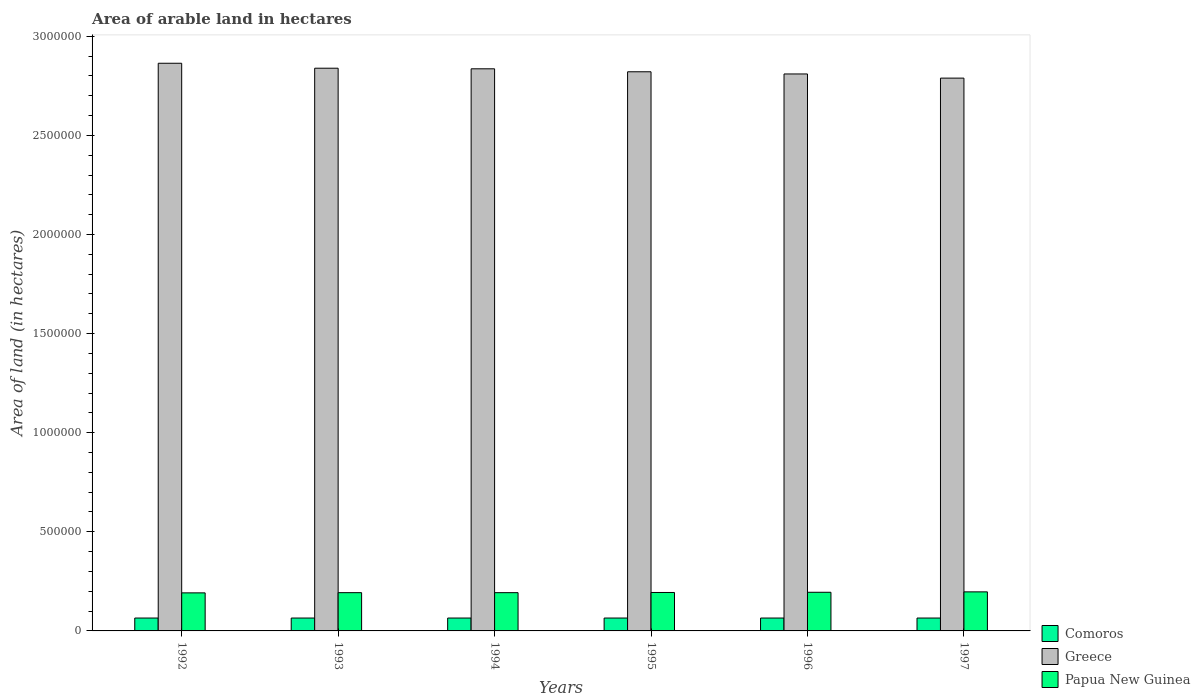How many groups of bars are there?
Offer a terse response. 6. Are the number of bars per tick equal to the number of legend labels?
Give a very brief answer. Yes. Are the number of bars on each tick of the X-axis equal?
Your answer should be very brief. Yes. What is the total arable land in Papua New Guinea in 1996?
Ensure brevity in your answer.  1.95e+05. Across all years, what is the maximum total arable land in Papua New Guinea?
Ensure brevity in your answer.  1.97e+05. Across all years, what is the minimum total arable land in Comoros?
Ensure brevity in your answer.  6.50e+04. In which year was the total arable land in Comoros maximum?
Offer a very short reply. 1992. In which year was the total arable land in Comoros minimum?
Make the answer very short. 1992. What is the total total arable land in Papua New Guinea in the graph?
Offer a very short reply. 1.16e+06. What is the difference between the total arable land in Papua New Guinea in 1992 and the total arable land in Comoros in 1997?
Provide a short and direct response. 1.27e+05. What is the average total arable land in Greece per year?
Offer a terse response. 2.83e+06. In the year 1997, what is the difference between the total arable land in Papua New Guinea and total arable land in Greece?
Give a very brief answer. -2.59e+06. What is the ratio of the total arable land in Greece in 1992 to that in 1997?
Provide a short and direct response. 1.03. Is the total arable land in Comoros in 1993 less than that in 1994?
Offer a terse response. No. Is the difference between the total arable land in Papua New Guinea in 1996 and 1997 greater than the difference between the total arable land in Greece in 1996 and 1997?
Offer a terse response. No. What is the difference between the highest and the lowest total arable land in Comoros?
Keep it short and to the point. 0. Is the sum of the total arable land in Comoros in 1996 and 1997 greater than the maximum total arable land in Papua New Guinea across all years?
Give a very brief answer. No. What does the 3rd bar from the left in 1994 represents?
Your answer should be compact. Papua New Guinea. What does the 1st bar from the right in 1992 represents?
Your answer should be very brief. Papua New Guinea. Is it the case that in every year, the sum of the total arable land in Greece and total arable land in Comoros is greater than the total arable land in Papua New Guinea?
Provide a short and direct response. Yes. How many bars are there?
Your answer should be very brief. 18. Are all the bars in the graph horizontal?
Your answer should be very brief. No. How many years are there in the graph?
Make the answer very short. 6. Are the values on the major ticks of Y-axis written in scientific E-notation?
Ensure brevity in your answer.  No. Where does the legend appear in the graph?
Your answer should be compact. Bottom right. How many legend labels are there?
Offer a terse response. 3. How are the legend labels stacked?
Provide a succinct answer. Vertical. What is the title of the graph?
Your answer should be compact. Area of arable land in hectares. Does "Venezuela" appear as one of the legend labels in the graph?
Ensure brevity in your answer.  No. What is the label or title of the X-axis?
Keep it short and to the point. Years. What is the label or title of the Y-axis?
Your answer should be compact. Area of land (in hectares). What is the Area of land (in hectares) of Comoros in 1992?
Offer a terse response. 6.50e+04. What is the Area of land (in hectares) of Greece in 1992?
Ensure brevity in your answer.  2.86e+06. What is the Area of land (in hectares) in Papua New Guinea in 1992?
Make the answer very short. 1.92e+05. What is the Area of land (in hectares) in Comoros in 1993?
Your response must be concise. 6.50e+04. What is the Area of land (in hectares) in Greece in 1993?
Give a very brief answer. 2.84e+06. What is the Area of land (in hectares) in Papua New Guinea in 1993?
Offer a very short reply. 1.93e+05. What is the Area of land (in hectares) of Comoros in 1994?
Provide a succinct answer. 6.50e+04. What is the Area of land (in hectares) of Greece in 1994?
Give a very brief answer. 2.84e+06. What is the Area of land (in hectares) of Papua New Guinea in 1994?
Keep it short and to the point. 1.93e+05. What is the Area of land (in hectares) in Comoros in 1995?
Provide a short and direct response. 6.50e+04. What is the Area of land (in hectares) in Greece in 1995?
Ensure brevity in your answer.  2.82e+06. What is the Area of land (in hectares) of Papua New Guinea in 1995?
Make the answer very short. 1.94e+05. What is the Area of land (in hectares) of Comoros in 1996?
Keep it short and to the point. 6.50e+04. What is the Area of land (in hectares) of Greece in 1996?
Your response must be concise. 2.81e+06. What is the Area of land (in hectares) in Papua New Guinea in 1996?
Your response must be concise. 1.95e+05. What is the Area of land (in hectares) in Comoros in 1997?
Offer a terse response. 6.50e+04. What is the Area of land (in hectares) in Greece in 1997?
Provide a short and direct response. 2.79e+06. What is the Area of land (in hectares) in Papua New Guinea in 1997?
Your response must be concise. 1.97e+05. Across all years, what is the maximum Area of land (in hectares) in Comoros?
Give a very brief answer. 6.50e+04. Across all years, what is the maximum Area of land (in hectares) in Greece?
Give a very brief answer. 2.86e+06. Across all years, what is the maximum Area of land (in hectares) of Papua New Guinea?
Ensure brevity in your answer.  1.97e+05. Across all years, what is the minimum Area of land (in hectares) in Comoros?
Your answer should be compact. 6.50e+04. Across all years, what is the minimum Area of land (in hectares) in Greece?
Keep it short and to the point. 2.79e+06. Across all years, what is the minimum Area of land (in hectares) of Papua New Guinea?
Make the answer very short. 1.92e+05. What is the total Area of land (in hectares) in Greece in the graph?
Make the answer very short. 1.70e+07. What is the total Area of land (in hectares) of Papua New Guinea in the graph?
Your response must be concise. 1.16e+06. What is the difference between the Area of land (in hectares) of Greece in 1992 and that in 1993?
Ensure brevity in your answer.  2.50e+04. What is the difference between the Area of land (in hectares) in Papua New Guinea in 1992 and that in 1993?
Provide a short and direct response. -1000. What is the difference between the Area of land (in hectares) in Greece in 1992 and that in 1994?
Provide a succinct answer. 2.80e+04. What is the difference between the Area of land (in hectares) in Papua New Guinea in 1992 and that in 1994?
Your answer should be compact. -1000. What is the difference between the Area of land (in hectares) in Comoros in 1992 and that in 1995?
Your answer should be compact. 0. What is the difference between the Area of land (in hectares) in Greece in 1992 and that in 1995?
Your answer should be very brief. 4.30e+04. What is the difference between the Area of land (in hectares) of Papua New Guinea in 1992 and that in 1995?
Your answer should be compact. -2000. What is the difference between the Area of land (in hectares) in Greece in 1992 and that in 1996?
Offer a terse response. 5.40e+04. What is the difference between the Area of land (in hectares) of Papua New Guinea in 1992 and that in 1996?
Provide a succinct answer. -3000. What is the difference between the Area of land (in hectares) of Greece in 1992 and that in 1997?
Provide a short and direct response. 7.50e+04. What is the difference between the Area of land (in hectares) in Papua New Guinea in 1992 and that in 1997?
Your response must be concise. -5000. What is the difference between the Area of land (in hectares) in Greece in 1993 and that in 1994?
Make the answer very short. 3000. What is the difference between the Area of land (in hectares) of Papua New Guinea in 1993 and that in 1994?
Offer a terse response. 0. What is the difference between the Area of land (in hectares) of Comoros in 1993 and that in 1995?
Your answer should be very brief. 0. What is the difference between the Area of land (in hectares) of Greece in 1993 and that in 1995?
Provide a short and direct response. 1.80e+04. What is the difference between the Area of land (in hectares) of Papua New Guinea in 1993 and that in 1995?
Make the answer very short. -1000. What is the difference between the Area of land (in hectares) of Comoros in 1993 and that in 1996?
Make the answer very short. 0. What is the difference between the Area of land (in hectares) in Greece in 1993 and that in 1996?
Ensure brevity in your answer.  2.90e+04. What is the difference between the Area of land (in hectares) in Papua New Guinea in 1993 and that in 1996?
Provide a short and direct response. -2000. What is the difference between the Area of land (in hectares) of Greece in 1993 and that in 1997?
Give a very brief answer. 5.00e+04. What is the difference between the Area of land (in hectares) in Papua New Guinea in 1993 and that in 1997?
Offer a terse response. -4000. What is the difference between the Area of land (in hectares) in Comoros in 1994 and that in 1995?
Provide a succinct answer. 0. What is the difference between the Area of land (in hectares) in Greece in 1994 and that in 1995?
Offer a terse response. 1.50e+04. What is the difference between the Area of land (in hectares) of Papua New Guinea in 1994 and that in 1995?
Your response must be concise. -1000. What is the difference between the Area of land (in hectares) of Greece in 1994 and that in 1996?
Offer a very short reply. 2.60e+04. What is the difference between the Area of land (in hectares) of Papua New Guinea in 1994 and that in 1996?
Offer a very short reply. -2000. What is the difference between the Area of land (in hectares) of Comoros in 1994 and that in 1997?
Make the answer very short. 0. What is the difference between the Area of land (in hectares) of Greece in 1994 and that in 1997?
Provide a succinct answer. 4.70e+04. What is the difference between the Area of land (in hectares) in Papua New Guinea in 1994 and that in 1997?
Offer a very short reply. -4000. What is the difference between the Area of land (in hectares) of Greece in 1995 and that in 1996?
Your answer should be very brief. 1.10e+04. What is the difference between the Area of land (in hectares) in Papua New Guinea in 1995 and that in 1996?
Offer a terse response. -1000. What is the difference between the Area of land (in hectares) of Greece in 1995 and that in 1997?
Your answer should be compact. 3.20e+04. What is the difference between the Area of land (in hectares) of Papua New Guinea in 1995 and that in 1997?
Provide a succinct answer. -3000. What is the difference between the Area of land (in hectares) in Greece in 1996 and that in 1997?
Provide a short and direct response. 2.10e+04. What is the difference between the Area of land (in hectares) of Papua New Guinea in 1996 and that in 1997?
Provide a short and direct response. -2000. What is the difference between the Area of land (in hectares) of Comoros in 1992 and the Area of land (in hectares) of Greece in 1993?
Offer a very short reply. -2.77e+06. What is the difference between the Area of land (in hectares) of Comoros in 1992 and the Area of land (in hectares) of Papua New Guinea in 1993?
Provide a succinct answer. -1.28e+05. What is the difference between the Area of land (in hectares) in Greece in 1992 and the Area of land (in hectares) in Papua New Guinea in 1993?
Make the answer very short. 2.67e+06. What is the difference between the Area of land (in hectares) of Comoros in 1992 and the Area of land (in hectares) of Greece in 1994?
Provide a succinct answer. -2.77e+06. What is the difference between the Area of land (in hectares) of Comoros in 1992 and the Area of land (in hectares) of Papua New Guinea in 1994?
Keep it short and to the point. -1.28e+05. What is the difference between the Area of land (in hectares) of Greece in 1992 and the Area of land (in hectares) of Papua New Guinea in 1994?
Provide a succinct answer. 2.67e+06. What is the difference between the Area of land (in hectares) of Comoros in 1992 and the Area of land (in hectares) of Greece in 1995?
Keep it short and to the point. -2.76e+06. What is the difference between the Area of land (in hectares) of Comoros in 1992 and the Area of land (in hectares) of Papua New Guinea in 1995?
Give a very brief answer. -1.29e+05. What is the difference between the Area of land (in hectares) in Greece in 1992 and the Area of land (in hectares) in Papua New Guinea in 1995?
Provide a succinct answer. 2.67e+06. What is the difference between the Area of land (in hectares) in Comoros in 1992 and the Area of land (in hectares) in Greece in 1996?
Offer a terse response. -2.74e+06. What is the difference between the Area of land (in hectares) in Greece in 1992 and the Area of land (in hectares) in Papua New Guinea in 1996?
Provide a short and direct response. 2.67e+06. What is the difference between the Area of land (in hectares) in Comoros in 1992 and the Area of land (in hectares) in Greece in 1997?
Your answer should be compact. -2.72e+06. What is the difference between the Area of land (in hectares) in Comoros in 1992 and the Area of land (in hectares) in Papua New Guinea in 1997?
Make the answer very short. -1.32e+05. What is the difference between the Area of land (in hectares) of Greece in 1992 and the Area of land (in hectares) of Papua New Guinea in 1997?
Your answer should be very brief. 2.67e+06. What is the difference between the Area of land (in hectares) of Comoros in 1993 and the Area of land (in hectares) of Greece in 1994?
Offer a very short reply. -2.77e+06. What is the difference between the Area of land (in hectares) in Comoros in 1993 and the Area of land (in hectares) in Papua New Guinea in 1994?
Make the answer very short. -1.28e+05. What is the difference between the Area of land (in hectares) of Greece in 1993 and the Area of land (in hectares) of Papua New Guinea in 1994?
Keep it short and to the point. 2.65e+06. What is the difference between the Area of land (in hectares) of Comoros in 1993 and the Area of land (in hectares) of Greece in 1995?
Provide a short and direct response. -2.76e+06. What is the difference between the Area of land (in hectares) of Comoros in 1993 and the Area of land (in hectares) of Papua New Guinea in 1995?
Keep it short and to the point. -1.29e+05. What is the difference between the Area of land (in hectares) in Greece in 1993 and the Area of land (in hectares) in Papua New Guinea in 1995?
Give a very brief answer. 2.64e+06. What is the difference between the Area of land (in hectares) in Comoros in 1993 and the Area of land (in hectares) in Greece in 1996?
Your answer should be compact. -2.74e+06. What is the difference between the Area of land (in hectares) of Greece in 1993 and the Area of land (in hectares) of Papua New Guinea in 1996?
Provide a short and direct response. 2.64e+06. What is the difference between the Area of land (in hectares) of Comoros in 1993 and the Area of land (in hectares) of Greece in 1997?
Offer a very short reply. -2.72e+06. What is the difference between the Area of land (in hectares) of Comoros in 1993 and the Area of land (in hectares) of Papua New Guinea in 1997?
Keep it short and to the point. -1.32e+05. What is the difference between the Area of land (in hectares) of Greece in 1993 and the Area of land (in hectares) of Papua New Guinea in 1997?
Your response must be concise. 2.64e+06. What is the difference between the Area of land (in hectares) in Comoros in 1994 and the Area of land (in hectares) in Greece in 1995?
Your answer should be compact. -2.76e+06. What is the difference between the Area of land (in hectares) of Comoros in 1994 and the Area of land (in hectares) of Papua New Guinea in 1995?
Offer a terse response. -1.29e+05. What is the difference between the Area of land (in hectares) of Greece in 1994 and the Area of land (in hectares) of Papua New Guinea in 1995?
Offer a very short reply. 2.64e+06. What is the difference between the Area of land (in hectares) in Comoros in 1994 and the Area of land (in hectares) in Greece in 1996?
Ensure brevity in your answer.  -2.74e+06. What is the difference between the Area of land (in hectares) of Greece in 1994 and the Area of land (in hectares) of Papua New Guinea in 1996?
Provide a succinct answer. 2.64e+06. What is the difference between the Area of land (in hectares) of Comoros in 1994 and the Area of land (in hectares) of Greece in 1997?
Keep it short and to the point. -2.72e+06. What is the difference between the Area of land (in hectares) of Comoros in 1994 and the Area of land (in hectares) of Papua New Guinea in 1997?
Your answer should be compact. -1.32e+05. What is the difference between the Area of land (in hectares) in Greece in 1994 and the Area of land (in hectares) in Papua New Guinea in 1997?
Keep it short and to the point. 2.64e+06. What is the difference between the Area of land (in hectares) in Comoros in 1995 and the Area of land (in hectares) in Greece in 1996?
Give a very brief answer. -2.74e+06. What is the difference between the Area of land (in hectares) of Greece in 1995 and the Area of land (in hectares) of Papua New Guinea in 1996?
Ensure brevity in your answer.  2.63e+06. What is the difference between the Area of land (in hectares) in Comoros in 1995 and the Area of land (in hectares) in Greece in 1997?
Your answer should be very brief. -2.72e+06. What is the difference between the Area of land (in hectares) in Comoros in 1995 and the Area of land (in hectares) in Papua New Guinea in 1997?
Provide a succinct answer. -1.32e+05. What is the difference between the Area of land (in hectares) in Greece in 1995 and the Area of land (in hectares) in Papua New Guinea in 1997?
Offer a terse response. 2.62e+06. What is the difference between the Area of land (in hectares) in Comoros in 1996 and the Area of land (in hectares) in Greece in 1997?
Make the answer very short. -2.72e+06. What is the difference between the Area of land (in hectares) of Comoros in 1996 and the Area of land (in hectares) of Papua New Guinea in 1997?
Make the answer very short. -1.32e+05. What is the difference between the Area of land (in hectares) in Greece in 1996 and the Area of land (in hectares) in Papua New Guinea in 1997?
Make the answer very short. 2.61e+06. What is the average Area of land (in hectares) of Comoros per year?
Give a very brief answer. 6.50e+04. What is the average Area of land (in hectares) of Greece per year?
Make the answer very short. 2.83e+06. What is the average Area of land (in hectares) of Papua New Guinea per year?
Your answer should be very brief. 1.94e+05. In the year 1992, what is the difference between the Area of land (in hectares) in Comoros and Area of land (in hectares) in Greece?
Offer a very short reply. -2.80e+06. In the year 1992, what is the difference between the Area of land (in hectares) of Comoros and Area of land (in hectares) of Papua New Guinea?
Offer a terse response. -1.27e+05. In the year 1992, what is the difference between the Area of land (in hectares) of Greece and Area of land (in hectares) of Papua New Guinea?
Keep it short and to the point. 2.67e+06. In the year 1993, what is the difference between the Area of land (in hectares) of Comoros and Area of land (in hectares) of Greece?
Your answer should be very brief. -2.77e+06. In the year 1993, what is the difference between the Area of land (in hectares) in Comoros and Area of land (in hectares) in Papua New Guinea?
Make the answer very short. -1.28e+05. In the year 1993, what is the difference between the Area of land (in hectares) in Greece and Area of land (in hectares) in Papua New Guinea?
Your response must be concise. 2.65e+06. In the year 1994, what is the difference between the Area of land (in hectares) in Comoros and Area of land (in hectares) in Greece?
Your response must be concise. -2.77e+06. In the year 1994, what is the difference between the Area of land (in hectares) in Comoros and Area of land (in hectares) in Papua New Guinea?
Provide a short and direct response. -1.28e+05. In the year 1994, what is the difference between the Area of land (in hectares) of Greece and Area of land (in hectares) of Papua New Guinea?
Ensure brevity in your answer.  2.64e+06. In the year 1995, what is the difference between the Area of land (in hectares) of Comoros and Area of land (in hectares) of Greece?
Your answer should be very brief. -2.76e+06. In the year 1995, what is the difference between the Area of land (in hectares) in Comoros and Area of land (in hectares) in Papua New Guinea?
Make the answer very short. -1.29e+05. In the year 1995, what is the difference between the Area of land (in hectares) in Greece and Area of land (in hectares) in Papua New Guinea?
Offer a very short reply. 2.63e+06. In the year 1996, what is the difference between the Area of land (in hectares) of Comoros and Area of land (in hectares) of Greece?
Offer a very short reply. -2.74e+06. In the year 1996, what is the difference between the Area of land (in hectares) of Comoros and Area of land (in hectares) of Papua New Guinea?
Provide a succinct answer. -1.30e+05. In the year 1996, what is the difference between the Area of land (in hectares) in Greece and Area of land (in hectares) in Papua New Guinea?
Give a very brief answer. 2.62e+06. In the year 1997, what is the difference between the Area of land (in hectares) of Comoros and Area of land (in hectares) of Greece?
Provide a short and direct response. -2.72e+06. In the year 1997, what is the difference between the Area of land (in hectares) in Comoros and Area of land (in hectares) in Papua New Guinea?
Provide a short and direct response. -1.32e+05. In the year 1997, what is the difference between the Area of land (in hectares) of Greece and Area of land (in hectares) of Papua New Guinea?
Offer a very short reply. 2.59e+06. What is the ratio of the Area of land (in hectares) of Greece in 1992 to that in 1993?
Your answer should be very brief. 1.01. What is the ratio of the Area of land (in hectares) of Comoros in 1992 to that in 1994?
Make the answer very short. 1. What is the ratio of the Area of land (in hectares) of Greece in 1992 to that in 1994?
Give a very brief answer. 1.01. What is the ratio of the Area of land (in hectares) in Greece in 1992 to that in 1995?
Give a very brief answer. 1.02. What is the ratio of the Area of land (in hectares) of Comoros in 1992 to that in 1996?
Ensure brevity in your answer.  1. What is the ratio of the Area of land (in hectares) of Greece in 1992 to that in 1996?
Give a very brief answer. 1.02. What is the ratio of the Area of land (in hectares) in Papua New Guinea in 1992 to that in 1996?
Provide a short and direct response. 0.98. What is the ratio of the Area of land (in hectares) of Greece in 1992 to that in 1997?
Your answer should be compact. 1.03. What is the ratio of the Area of land (in hectares) in Papua New Guinea in 1992 to that in 1997?
Offer a terse response. 0.97. What is the ratio of the Area of land (in hectares) in Greece in 1993 to that in 1994?
Your answer should be very brief. 1. What is the ratio of the Area of land (in hectares) in Papua New Guinea in 1993 to that in 1994?
Offer a very short reply. 1. What is the ratio of the Area of land (in hectares) of Greece in 1993 to that in 1995?
Your response must be concise. 1.01. What is the ratio of the Area of land (in hectares) of Comoros in 1993 to that in 1996?
Make the answer very short. 1. What is the ratio of the Area of land (in hectares) in Greece in 1993 to that in 1996?
Your response must be concise. 1.01. What is the ratio of the Area of land (in hectares) of Greece in 1993 to that in 1997?
Give a very brief answer. 1.02. What is the ratio of the Area of land (in hectares) of Papua New Guinea in 1993 to that in 1997?
Your answer should be compact. 0.98. What is the ratio of the Area of land (in hectares) of Greece in 1994 to that in 1995?
Offer a terse response. 1.01. What is the ratio of the Area of land (in hectares) in Papua New Guinea in 1994 to that in 1995?
Your response must be concise. 0.99. What is the ratio of the Area of land (in hectares) of Comoros in 1994 to that in 1996?
Your answer should be compact. 1. What is the ratio of the Area of land (in hectares) in Greece in 1994 to that in 1996?
Give a very brief answer. 1.01. What is the ratio of the Area of land (in hectares) of Papua New Guinea in 1994 to that in 1996?
Offer a very short reply. 0.99. What is the ratio of the Area of land (in hectares) in Greece in 1994 to that in 1997?
Give a very brief answer. 1.02. What is the ratio of the Area of land (in hectares) of Papua New Guinea in 1994 to that in 1997?
Provide a succinct answer. 0.98. What is the ratio of the Area of land (in hectares) in Comoros in 1995 to that in 1996?
Make the answer very short. 1. What is the ratio of the Area of land (in hectares) of Papua New Guinea in 1995 to that in 1996?
Provide a succinct answer. 0.99. What is the ratio of the Area of land (in hectares) of Comoros in 1995 to that in 1997?
Provide a succinct answer. 1. What is the ratio of the Area of land (in hectares) of Greece in 1995 to that in 1997?
Make the answer very short. 1.01. What is the ratio of the Area of land (in hectares) in Papua New Guinea in 1995 to that in 1997?
Your answer should be very brief. 0.98. What is the ratio of the Area of land (in hectares) in Greece in 1996 to that in 1997?
Offer a very short reply. 1.01. What is the ratio of the Area of land (in hectares) in Papua New Guinea in 1996 to that in 1997?
Keep it short and to the point. 0.99. What is the difference between the highest and the second highest Area of land (in hectares) in Greece?
Offer a very short reply. 2.50e+04. What is the difference between the highest and the lowest Area of land (in hectares) in Comoros?
Your answer should be compact. 0. What is the difference between the highest and the lowest Area of land (in hectares) of Greece?
Ensure brevity in your answer.  7.50e+04. What is the difference between the highest and the lowest Area of land (in hectares) of Papua New Guinea?
Your answer should be very brief. 5000. 